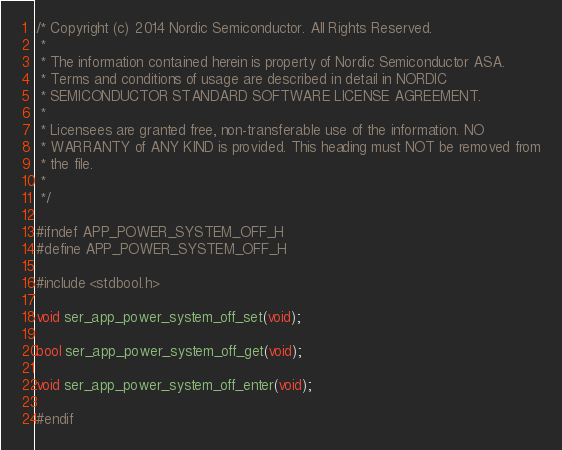Convert code to text. <code><loc_0><loc_0><loc_500><loc_500><_C_>/* Copyright (c) 2014 Nordic Semiconductor. All Rights Reserved.
 *
 * The information contained herein is property of Nordic Semiconductor ASA.
 * Terms and conditions of usage are described in detail in NORDIC
 * SEMICONDUCTOR STANDARD SOFTWARE LICENSE AGREEMENT.
 *
 * Licensees are granted free, non-transferable use of the information. NO
 * WARRANTY of ANY KIND is provided. This heading must NOT be removed from
 * the file.
 *
 */

#ifndef APP_POWER_SYSTEM_OFF_H
#define APP_POWER_SYSTEM_OFF_H

#include <stdbool.h>

void ser_app_power_system_off_set(void);

bool ser_app_power_system_off_get(void);

void ser_app_power_system_off_enter(void);

#endif
</code> 